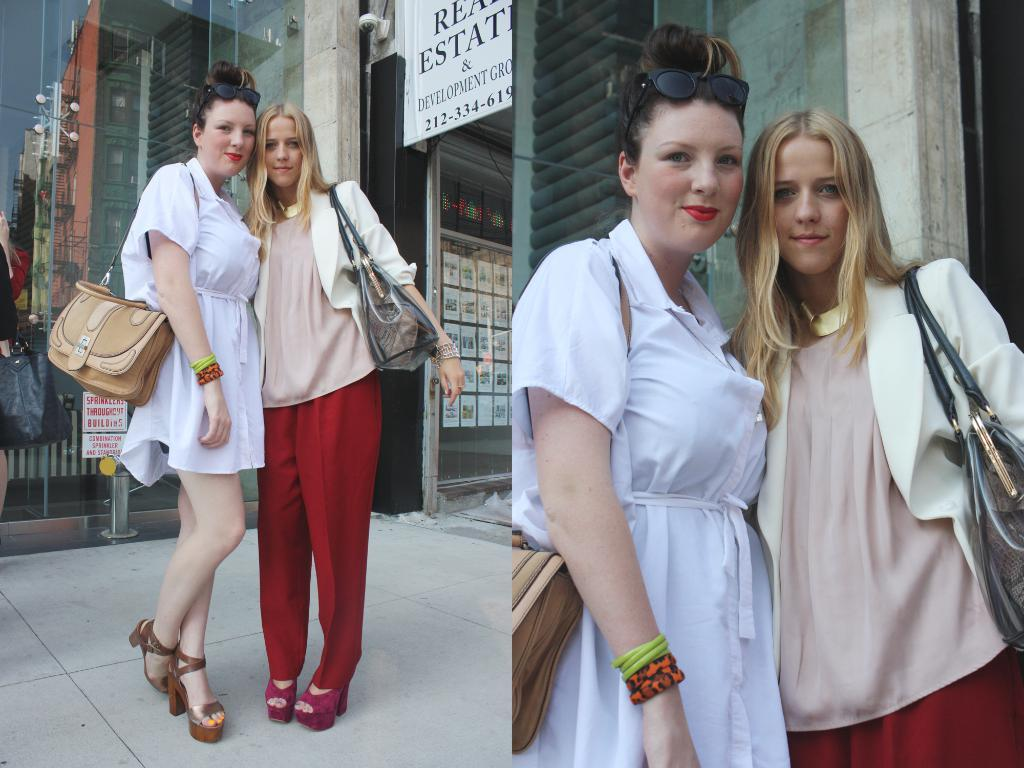How many people are in the image? There are two women in the image. What are the women doing in the image? The women are standing on the floor. What are the women holding in the image? The women are holding handbags. What can be seen in the background of the image? There is a store visible in the background of the image. How many geese are visible in the image? There are no geese present in the image. What type of lamp is on the table in the image? There is no lamp present in the image. 